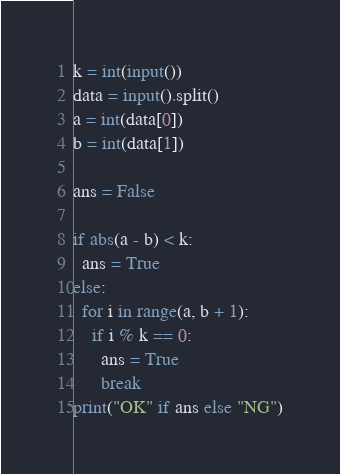<code> <loc_0><loc_0><loc_500><loc_500><_Python_>k = int(input())
data = input().split()
a = int(data[0])
b = int(data[1])
 
ans = False
 
if abs(a - b) < k:
  ans = True
else:
  for i in range(a, b + 1):
    if i % k == 0:
      ans = True
      break
print("OK" if ans else "NG")</code> 